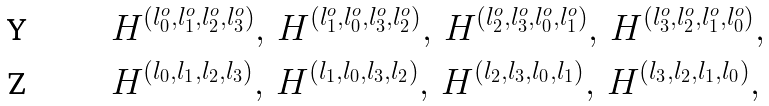<formula> <loc_0><loc_0><loc_500><loc_500>& H ^ { ( l _ { 0 } ^ { o } , l _ { 1 } ^ { o } , l _ { 2 } ^ { o } , l _ { 3 } ^ { o } ) } , \, H ^ { ( l _ { 1 } ^ { o } , l _ { 0 } ^ { o } , l _ { 3 } ^ { o } , l _ { 2 } ^ { o } ) } , \, H ^ { ( l _ { 2 } ^ { o } , l _ { 3 } ^ { o } , l _ { 0 } ^ { o } , l _ { 1 } ^ { o } ) } , \, H ^ { ( l _ { 3 } ^ { o } , l _ { 2 } ^ { o } , l _ { 1 } ^ { o } , l _ { 0 } ^ { o } ) } , \\ & H ^ { ( l _ { 0 } , l _ { 1 } , l _ { 2 } , l _ { 3 } ) } , \, H ^ { ( l _ { 1 } , l _ { 0 } , l _ { 3 } , l _ { 2 } ) } , \, H ^ { ( l _ { 2 } , l _ { 3 } , l _ { 0 } , l _ { 1 } ) } , \, H ^ { ( l _ { 3 } , l _ { 2 } , l _ { 1 } , l _ { 0 } ) } ,</formula> 